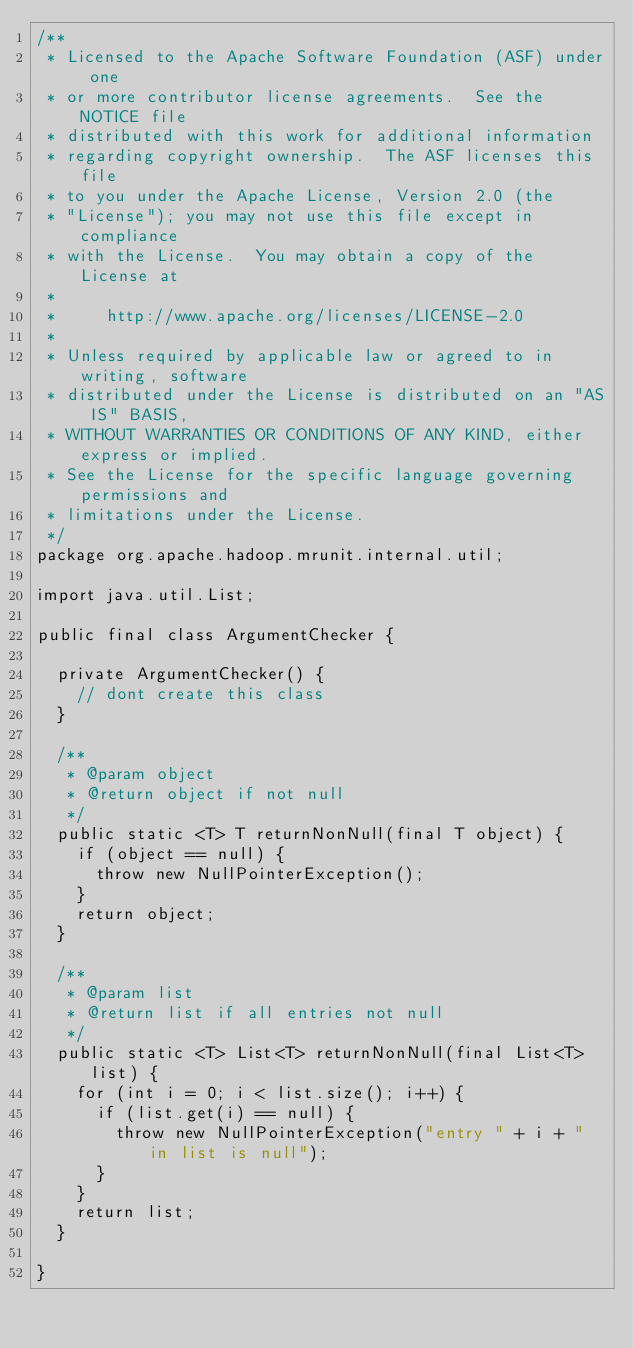Convert code to text. <code><loc_0><loc_0><loc_500><loc_500><_Java_>/**
 * Licensed to the Apache Software Foundation (ASF) under one
 * or more contributor license agreements.  See the NOTICE file
 * distributed with this work for additional information
 * regarding copyright ownership.  The ASF licenses this file
 * to you under the Apache License, Version 2.0 (the
 * "License"); you may not use this file except in compliance
 * with the License.  You may obtain a copy of the License at
 *
 *     http://www.apache.org/licenses/LICENSE-2.0
 *
 * Unless required by applicable law or agreed to in writing, software
 * distributed under the License is distributed on an "AS IS" BASIS,
 * WITHOUT WARRANTIES OR CONDITIONS OF ANY KIND, either express or implied.
 * See the License for the specific language governing permissions and
 * limitations under the License.
 */
package org.apache.hadoop.mrunit.internal.util;

import java.util.List;

public final class ArgumentChecker {

  private ArgumentChecker() {
    // dont create this class
  }

  /**
   * @param object
   * @return object if not null
   */
  public static <T> T returnNonNull(final T object) {
    if (object == null) {
      throw new NullPointerException();
    }
    return object;
  }

  /**
   * @param list
   * @return list if all entries not null
   */
  public static <T> List<T> returnNonNull(final List<T> list) {
    for (int i = 0; i < list.size(); i++) {
      if (list.get(i) == null) {
        throw new NullPointerException("entry " + i + " in list is null");
      }
    }
    return list;
  }

}
</code> 